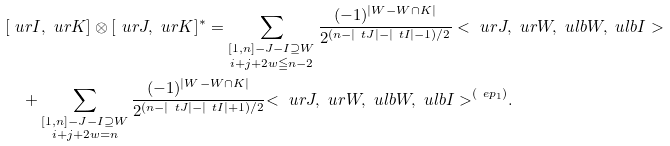Convert formula to latex. <formula><loc_0><loc_0><loc_500><loc_500>& [ \ u r { I } , \ u r { K } ] \otimes [ \ u r { J } , \ u r { K } ] ^ { * } = \sum _ { \substack { [ 1 , n ] - J - I \supseteq W \\ i + j + 2 w \leqq n - 2 } } \frac { ( - 1 ) ^ { | W - W \cap K | } } { 2 ^ { ( n - | \ t J | - | \ t I | - 1 ) / 2 } } < \ u r { J } , \ u r { W } , \ u l b { W } , \ u l b { I } > \\ & \quad + \sum _ { \substack { [ 1 , n ] - J - I \supseteq W \\ i + j + 2 w = n } } \frac { ( - 1 ) ^ { | W - W \cap K | } } { 2 ^ { ( n - | \ t J | - | \ t I | + 1 ) / 2 } } { < \ u r { J } , \ u r { W } , \ u l b { W } , \ u l b { I } > } ^ { ( \ e p _ { 1 } ) } . \\</formula> 